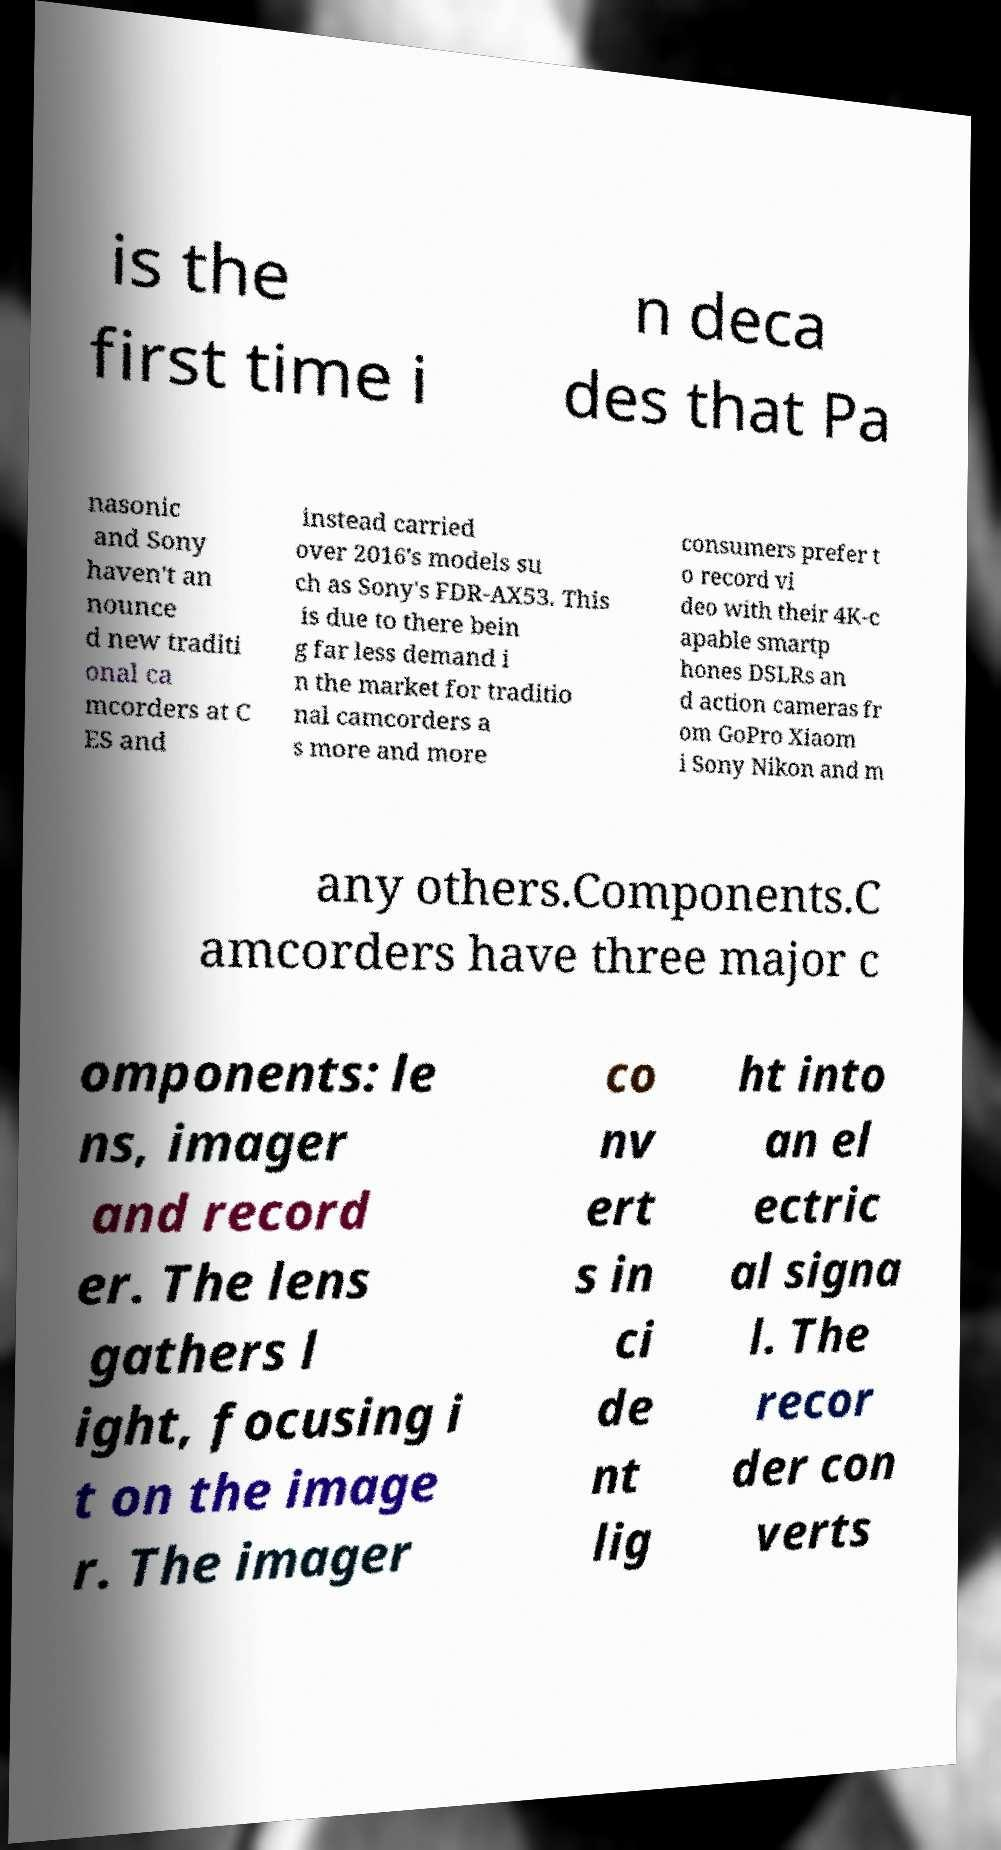For documentation purposes, I need the text within this image transcribed. Could you provide that? is the first time i n deca des that Pa nasonic and Sony haven't an nounce d new traditi onal ca mcorders at C ES and instead carried over 2016's models su ch as Sony's FDR-AX53. This is due to there bein g far less demand i n the market for traditio nal camcorders a s more and more consumers prefer t o record vi deo with their 4K-c apable smartp hones DSLRs an d action cameras fr om GoPro Xiaom i Sony Nikon and m any others.Components.C amcorders have three major c omponents: le ns, imager and record er. The lens gathers l ight, focusing i t on the image r. The imager co nv ert s in ci de nt lig ht into an el ectric al signa l. The recor der con verts 